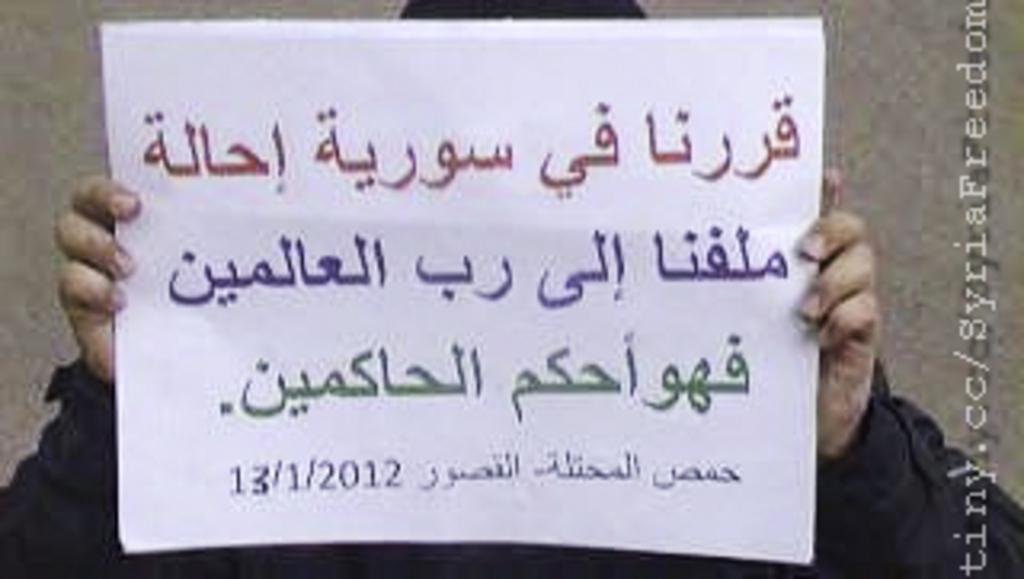What is the website on this image?
Provide a short and direct response. Tiny.cc/syriafreedom. What is the date listed on the piece of paper?
Keep it short and to the point. 13/1/2012. 